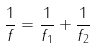<formula> <loc_0><loc_0><loc_500><loc_500>\frac { 1 } { f } = \frac { 1 } { f _ { 1 } } + \frac { 1 } { f _ { 2 } }</formula> 